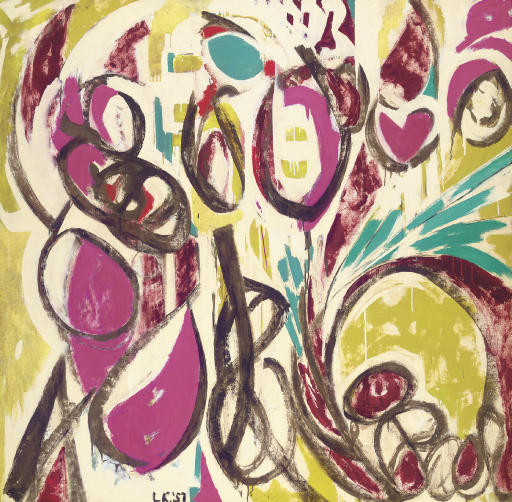Explain the visual content of the image in great detail. The image showcases an abstract expressionist art piece. It bursts with vibrant colors and dynamic shapes, lending a sense of liveliness and motion. Dominant colors include shades of pink, yellow, and green, scattered across the canvas in a blend that, while seemingly chaotic, achieves a surprising harmony. The style is reminiscent of graffiti or street art, characterized by bold, assertive lines and forms. The shapes vary, including sweeping lines and concentric circles, generating movement and energy. The brushstrokes show variation in texture, adding layers of depth and complexity to the piece. In the bottom left corner, the artist's signature 'Léon' is found, imparting a personal touch to this expressive creation. 